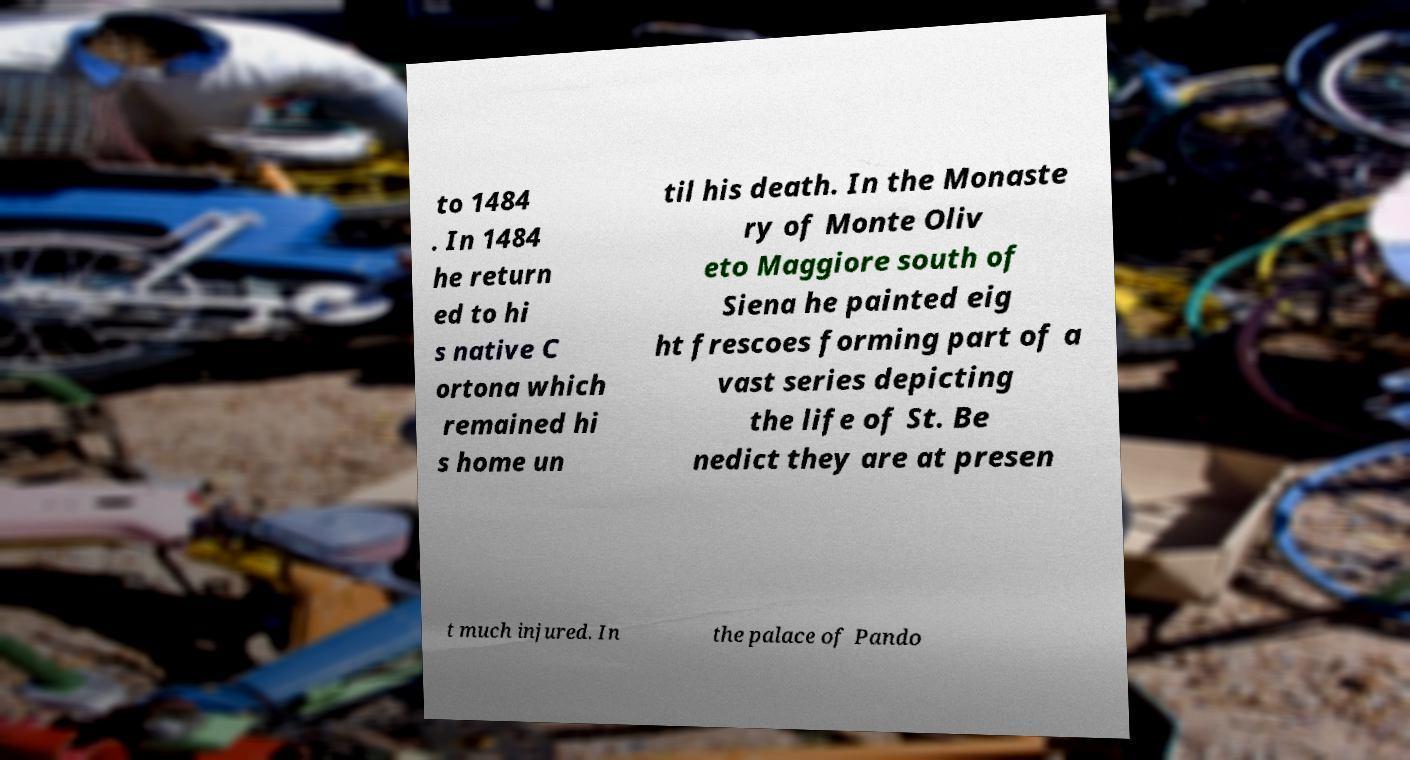For documentation purposes, I need the text within this image transcribed. Could you provide that? to 1484 . In 1484 he return ed to hi s native C ortona which remained hi s home un til his death. In the Monaste ry of Monte Oliv eto Maggiore south of Siena he painted eig ht frescoes forming part of a vast series depicting the life of St. Be nedict they are at presen t much injured. In the palace of Pando 